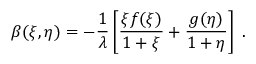<formula> <loc_0><loc_0><loc_500><loc_500>\beta ( \xi , \eta ) = - { \frac { 1 } { \lambda } } \left [ { \frac { \xi f ( \xi ) } { 1 + \xi } } + { \frac { g ( \eta ) } { 1 + \eta } } \right ] \, .</formula> 